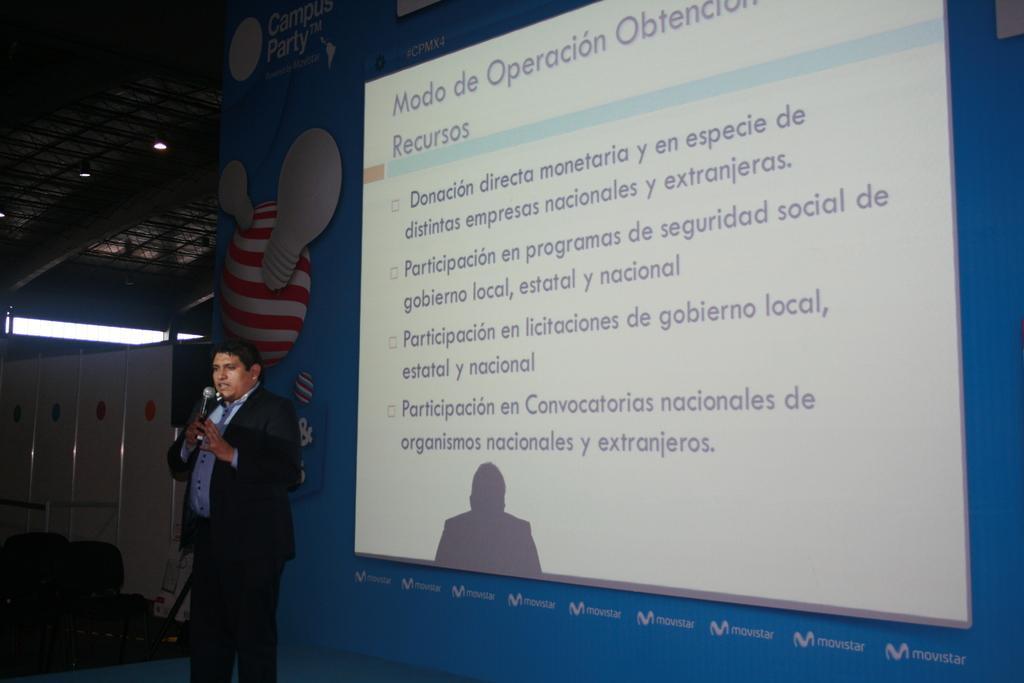Please provide a concise description of this image. In this image I can see a hoarding board , on the hoarding board I can see a screen and I can see a person standing in front the board, holding a mike and wearing a black color suit, on the left side I can see a light. 